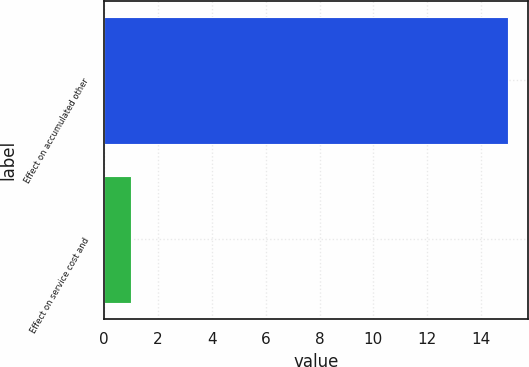Convert chart to OTSL. <chart><loc_0><loc_0><loc_500><loc_500><bar_chart><fcel>Effect on accumulated other<fcel>Effect on service cost and<nl><fcel>15<fcel>1<nl></chart> 